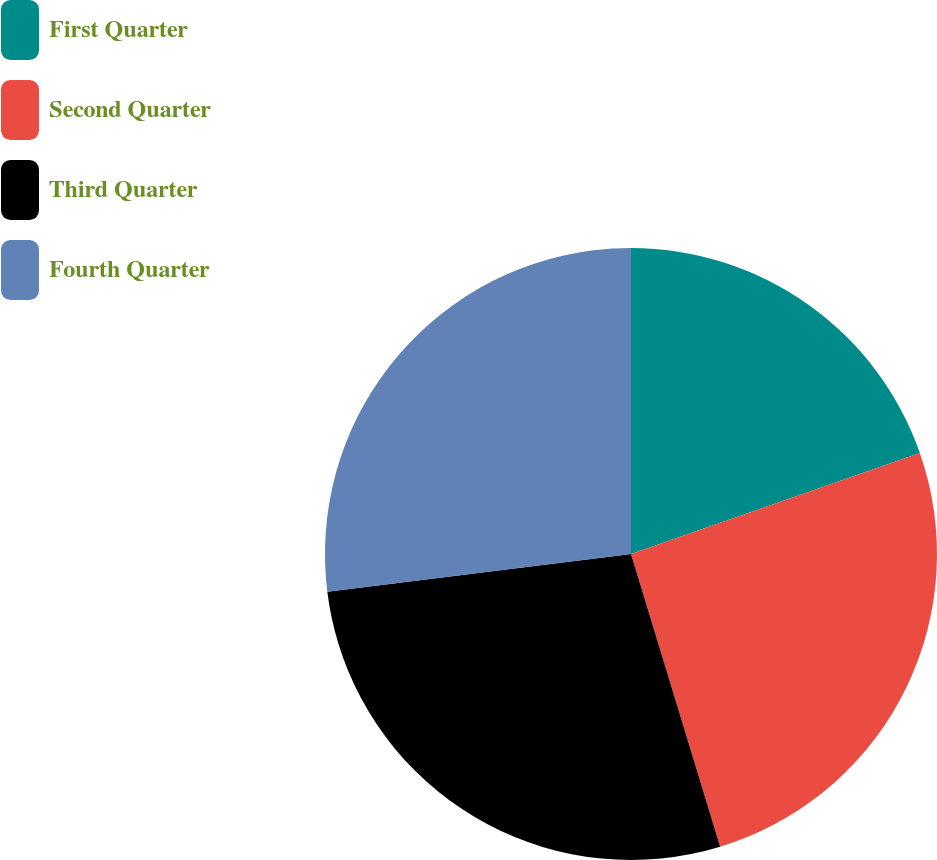Convert chart. <chart><loc_0><loc_0><loc_500><loc_500><pie_chart><fcel>First Quarter<fcel>Second Quarter<fcel>Third Quarter<fcel>Fourth Quarter<nl><fcel>19.64%<fcel>25.65%<fcel>27.74%<fcel>26.96%<nl></chart> 